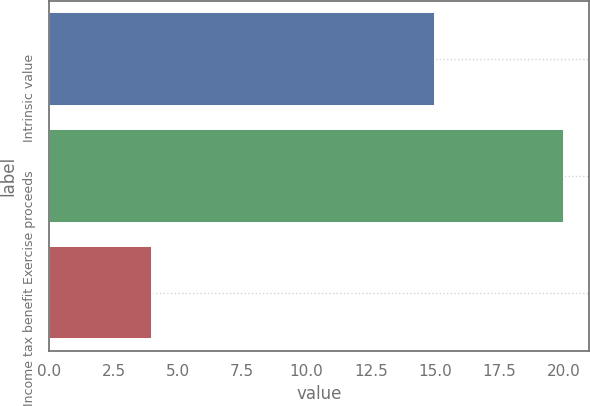Convert chart. <chart><loc_0><loc_0><loc_500><loc_500><bar_chart><fcel>Intrinsic value<fcel>Exercise proceeds<fcel>Income tax benefit<nl><fcel>15<fcel>20<fcel>4<nl></chart> 